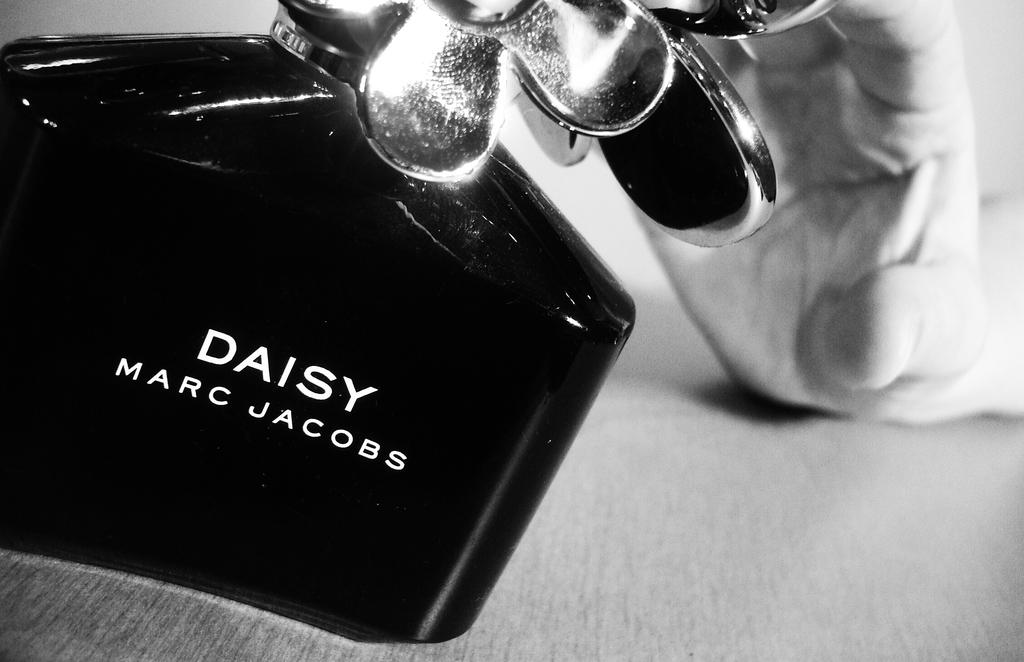<image>
Create a compact narrative representing the image presented. A bottle of perfume by Marc Jacobs with a hand behind it. 